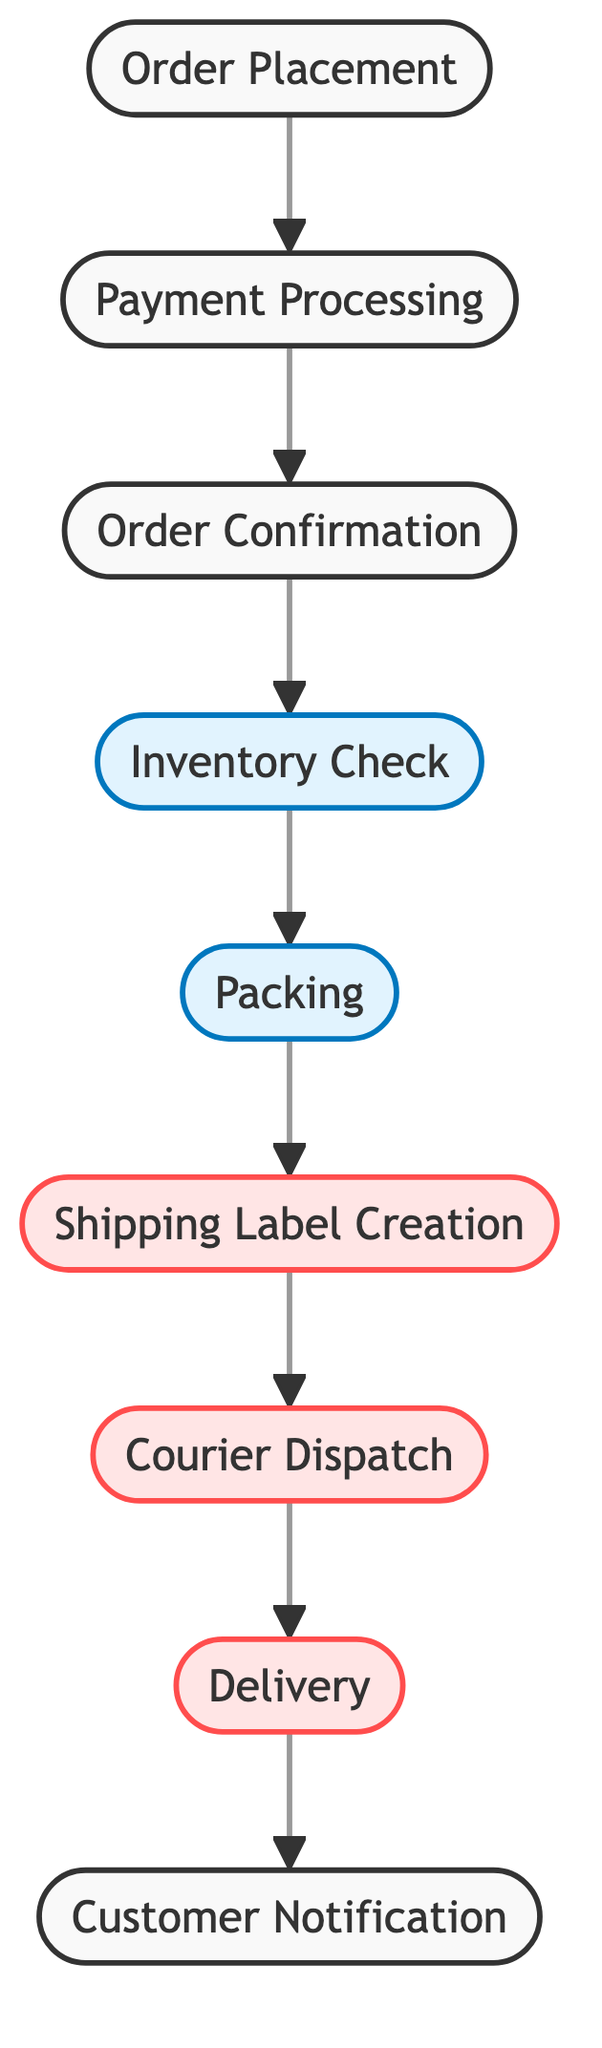What is the first step in the order fulfillment process? The diagram begins with "Order Placement" as the first node. This indicates the initial action that starts the order fulfillment process.
Answer: Order Placement How many steps are there in the order fulfillment process? By counting the nodes in the diagram, there are a total of nine distinct steps involved in the order fulfillment process.
Answer: Nine What comes after Payment Processing? Following the "Payment Processing" node, the next step indicated in the diagram is "Order Confirmation." This flow shows the progression from payment to confirmation.
Answer: Order Confirmation Is Packaging directly connected to Order Confirmation? The diagram does not show a direct connection between "Order Confirmation" and "Packing." Instead, the flow goes from "Order Confirmation" to "Inventory Check" before leading to "Packing."
Answer: No How many edges are there in the diagram? The diagram has eight edges that represent the connections between the nodes. Counting these connections gives the total number of edges.
Answer: Eight What are the last two steps in the process? The final two steps, according to the flow of the diagram starting from the last node back, are "Delivery" and "Customer Notification." This shows the conclusion of the fulfillment process.
Answer: Delivery, Customer Notification Which step comes before Shipping Label Creation? From the diagram's flow, "Packing" is the step that directly precedes "Shipping Label Creation." Therefore, packing is completed prior to creating a shipping label.
Answer: Packing What does the edge between Packing and Shipping Label Creation represent? The edge signifies the transition or progression from the "Packing" step to the "Shipping Label Creation" step in the order fulfillment process. It shows the order of operations required to fulfill an order.
Answer: Transition Which step directly leads to Customer Notification? The step that leads directly to "Customer Notification" is "Delivery," indicating that once delivery occurs, the customer is then notified.
Answer: Delivery 